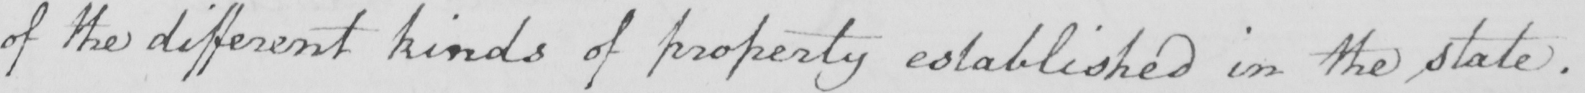What does this handwritten line say? of the different kinds of property established in the state . 